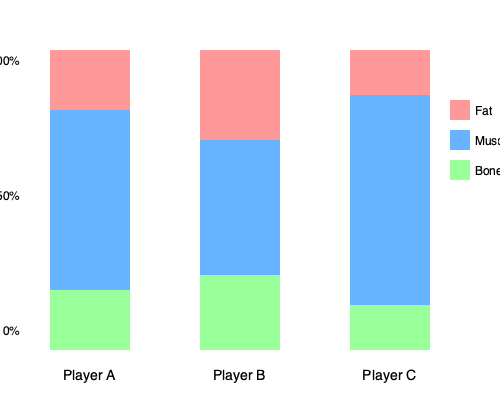As a coach concerned with team image and performance, which player's body composition would you consider most ideal for optimal athletic performance, and why? To determine the ideal body composition for optimal athletic performance, we need to analyze the percentages of fat, muscle, and bone for each player:

1. Player A:
   Fat: 20%
   Muscle: 60%
   Bone: 20%

2. Player B:
   Fat: 30%
   Muscle: 45%
   Bone: 25%

3. Player C:
   Fat: 15%
   Muscle: 70%
   Bone: 15%

Considering athletic performance:

1. Fat percentage: Lower body fat is generally better for most sports, as it reduces unnecessary weight and improves agility. Player C has the lowest fat percentage at 15%.

2. Muscle percentage: Higher muscle mass typically correlates with increased strength, power, and endurance. Player C has the highest muscle percentage at 70%.

3. Bone percentage: While important for overall health, bone density doesn't typically vary significantly between athletes and doesn't directly impact performance as much as fat and muscle. All players are within a normal range.

Player C has the most ideal composition with the lowest fat percentage and highest muscle percentage. This combination would likely result in the best strength-to-weight ratio, potentially leading to improved speed, agility, and overall athletic performance.

As a coach concerned with team image and performance, Player C's body composition would be most desirable, as it represents a highly fit and athletic physique that could contribute to both on-field performance and the team's professional image.
Answer: Player C, due to lowest fat (15%) and highest muscle (70%) percentages. 